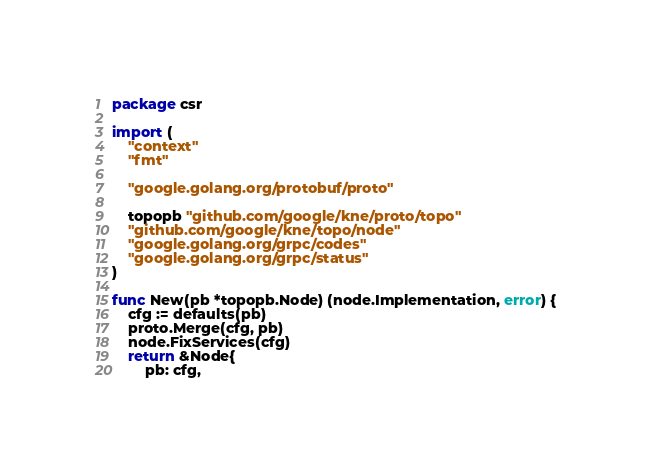<code> <loc_0><loc_0><loc_500><loc_500><_Go_>package csr

import (
	"context"
	"fmt"

	"google.golang.org/protobuf/proto"

	topopb "github.com/google/kne/proto/topo"
	"github.com/google/kne/topo/node"
	"google.golang.org/grpc/codes"
	"google.golang.org/grpc/status"
)

func New(pb *topopb.Node) (node.Implementation, error) {
	cfg := defaults(pb)
	proto.Merge(cfg, pb)
	node.FixServices(cfg)
	return &Node{
		pb: cfg,</code> 